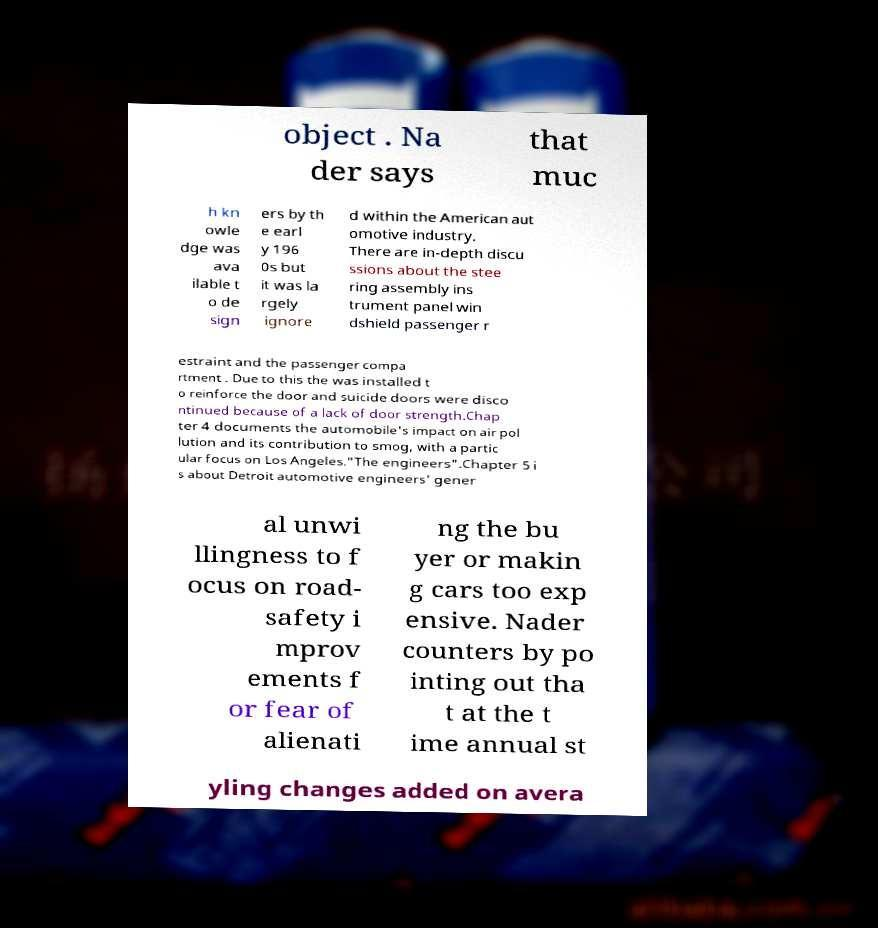Can you read and provide the text displayed in the image?This photo seems to have some interesting text. Can you extract and type it out for me? object . Na der says that muc h kn owle dge was ava ilable t o de sign ers by th e earl y 196 0s but it was la rgely ignore d within the American aut omotive industry. There are in-depth discu ssions about the stee ring assembly ins trument panel win dshield passenger r estraint and the passenger compa rtment . Due to this the was installed t o reinforce the door and suicide doors were disco ntinued because of a lack of door strength.Chap ter 4 documents the automobile's impact on air pol lution and its contribution to smog, with a partic ular focus on Los Angeles."The engineers".Chapter 5 i s about Detroit automotive engineers' gener al unwi llingness to f ocus on road- safety i mprov ements f or fear of alienati ng the bu yer or makin g cars too exp ensive. Nader counters by po inting out tha t at the t ime annual st yling changes added on avera 